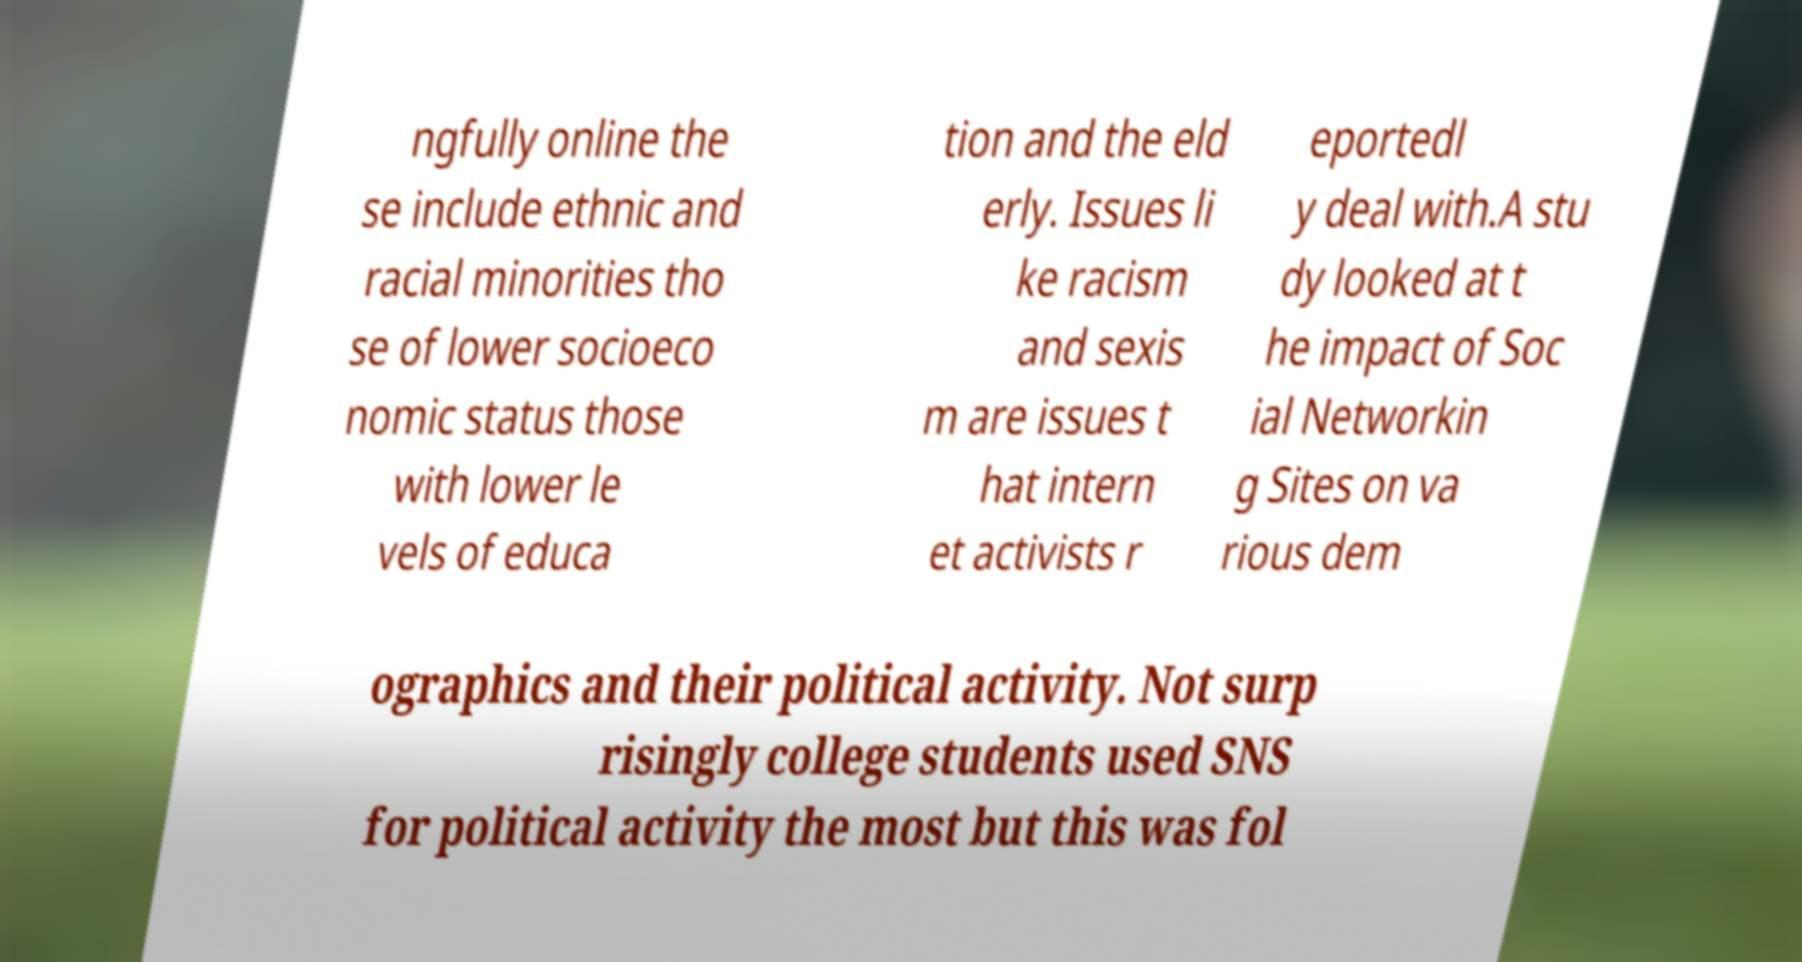Please read and relay the text visible in this image. What does it say? ngfully online the se include ethnic and racial minorities tho se of lower socioeco nomic status those with lower le vels of educa tion and the eld erly. Issues li ke racism and sexis m are issues t hat intern et activists r eportedl y deal with.A stu dy looked at t he impact of Soc ial Networkin g Sites on va rious dem ographics and their political activity. Not surp risingly college students used SNS for political activity the most but this was fol 